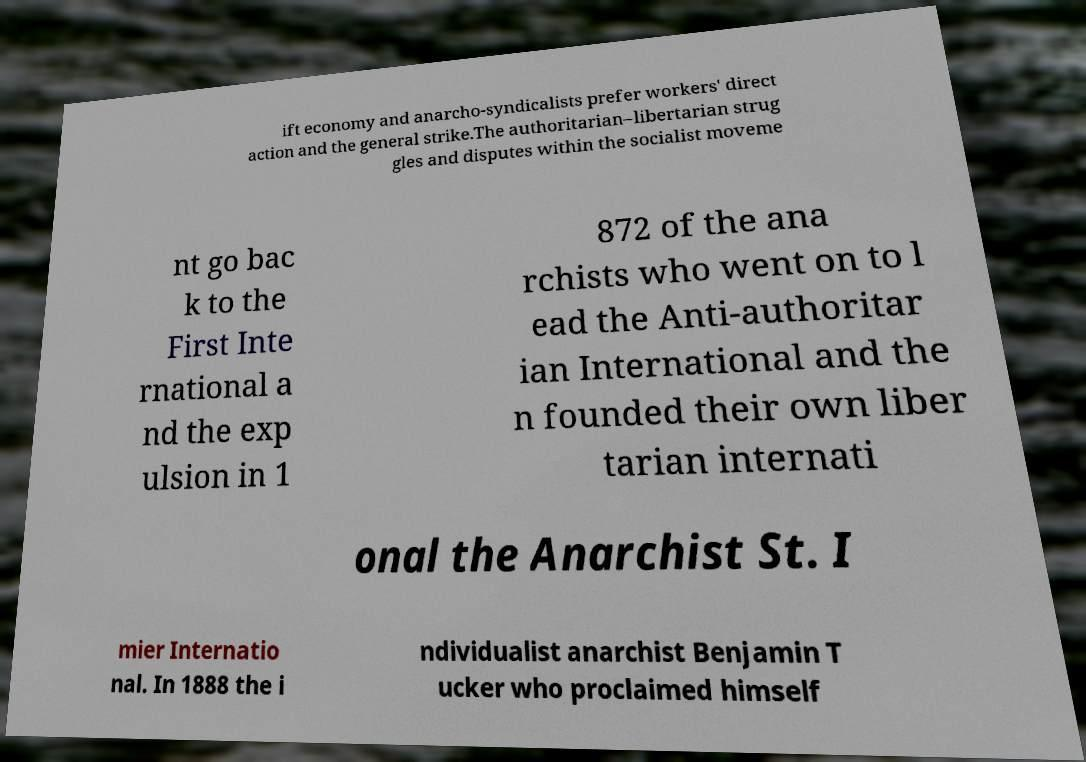There's text embedded in this image that I need extracted. Can you transcribe it verbatim? ift economy and anarcho-syndicalists prefer workers' direct action and the general strike.The authoritarian–libertarian strug gles and disputes within the socialist moveme nt go bac k to the First Inte rnational a nd the exp ulsion in 1 872 of the ana rchists who went on to l ead the Anti-authoritar ian International and the n founded their own liber tarian internati onal the Anarchist St. I mier Internatio nal. In 1888 the i ndividualist anarchist Benjamin T ucker who proclaimed himself 